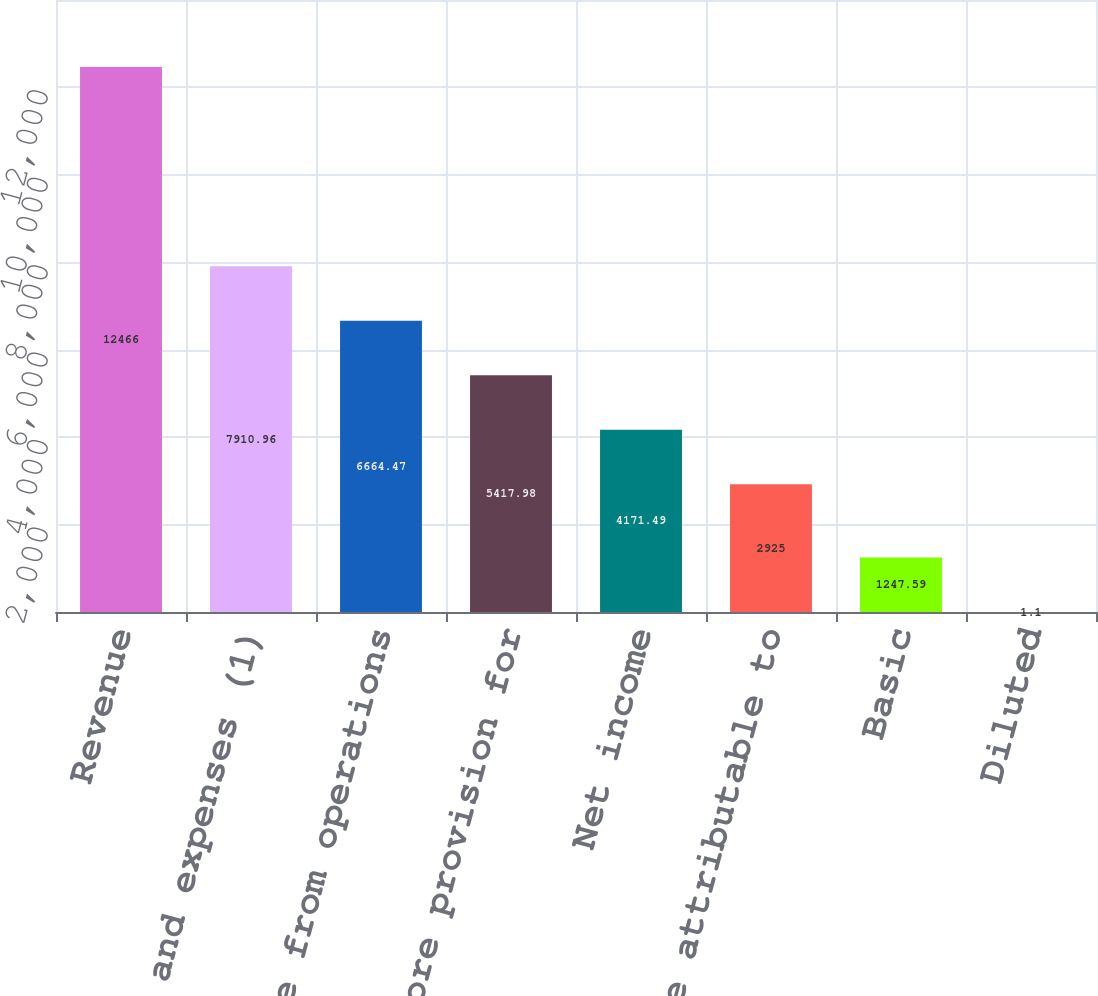Convert chart to OTSL. <chart><loc_0><loc_0><loc_500><loc_500><bar_chart><fcel>Revenue<fcel>Total costs and expenses (1)<fcel>Income from operations<fcel>Income before provision for<fcel>Net income<fcel>Net income attributable to<fcel>Basic<fcel>Diluted<nl><fcel>12466<fcel>7910.96<fcel>6664.47<fcel>5417.98<fcel>4171.49<fcel>2925<fcel>1247.59<fcel>1.1<nl></chart> 